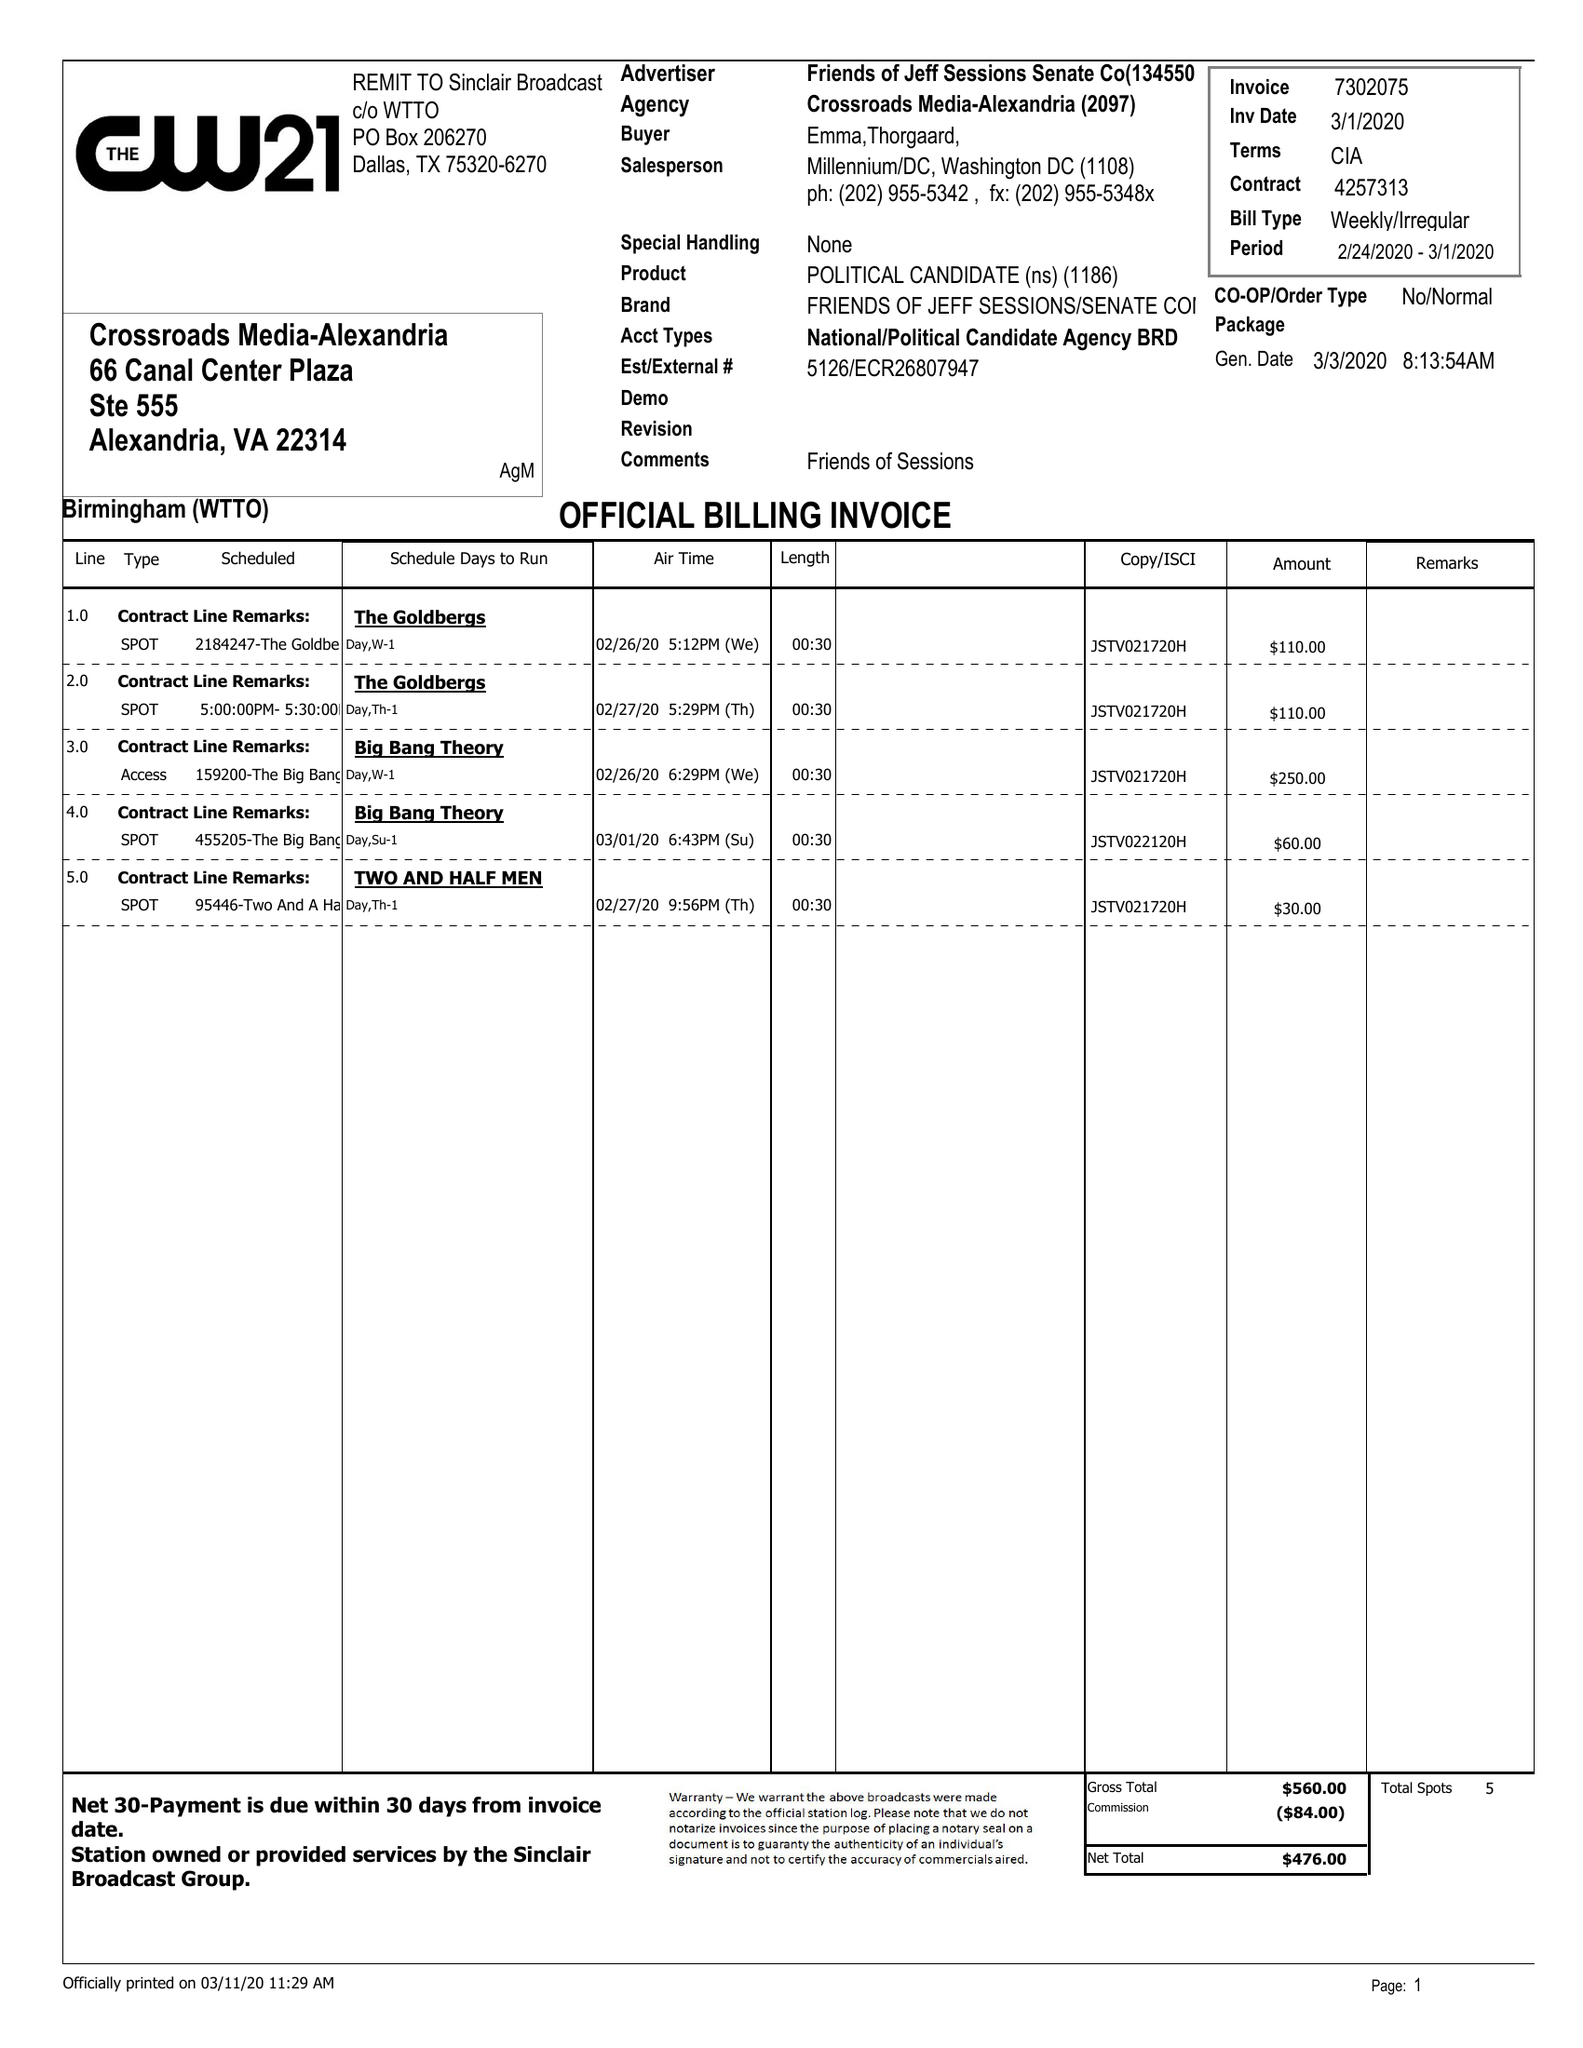What is the value for the contract_num?
Answer the question using a single word or phrase. 4257313 